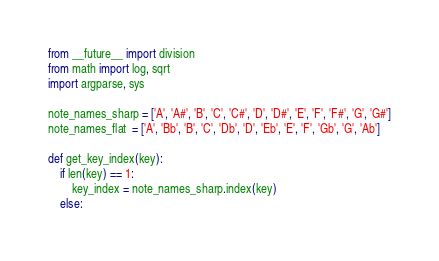Convert code to text. <code><loc_0><loc_0><loc_500><loc_500><_Python_>from __future__ import division
from math import log, sqrt
import argparse, sys

note_names_sharp = ['A', 'A#', 'B', 'C', 'C#', 'D', 'D#', 'E', 'F', 'F#', 'G', 'G#']
note_names_flat  = ['A', 'Bb', 'B', 'C', 'Db', 'D', 'Eb', 'E', 'F', 'Gb', 'G', 'Ab']

def get_key_index(key):
    if len(key) == 1:
        key_index = note_names_sharp.index(key)
    else:</code> 